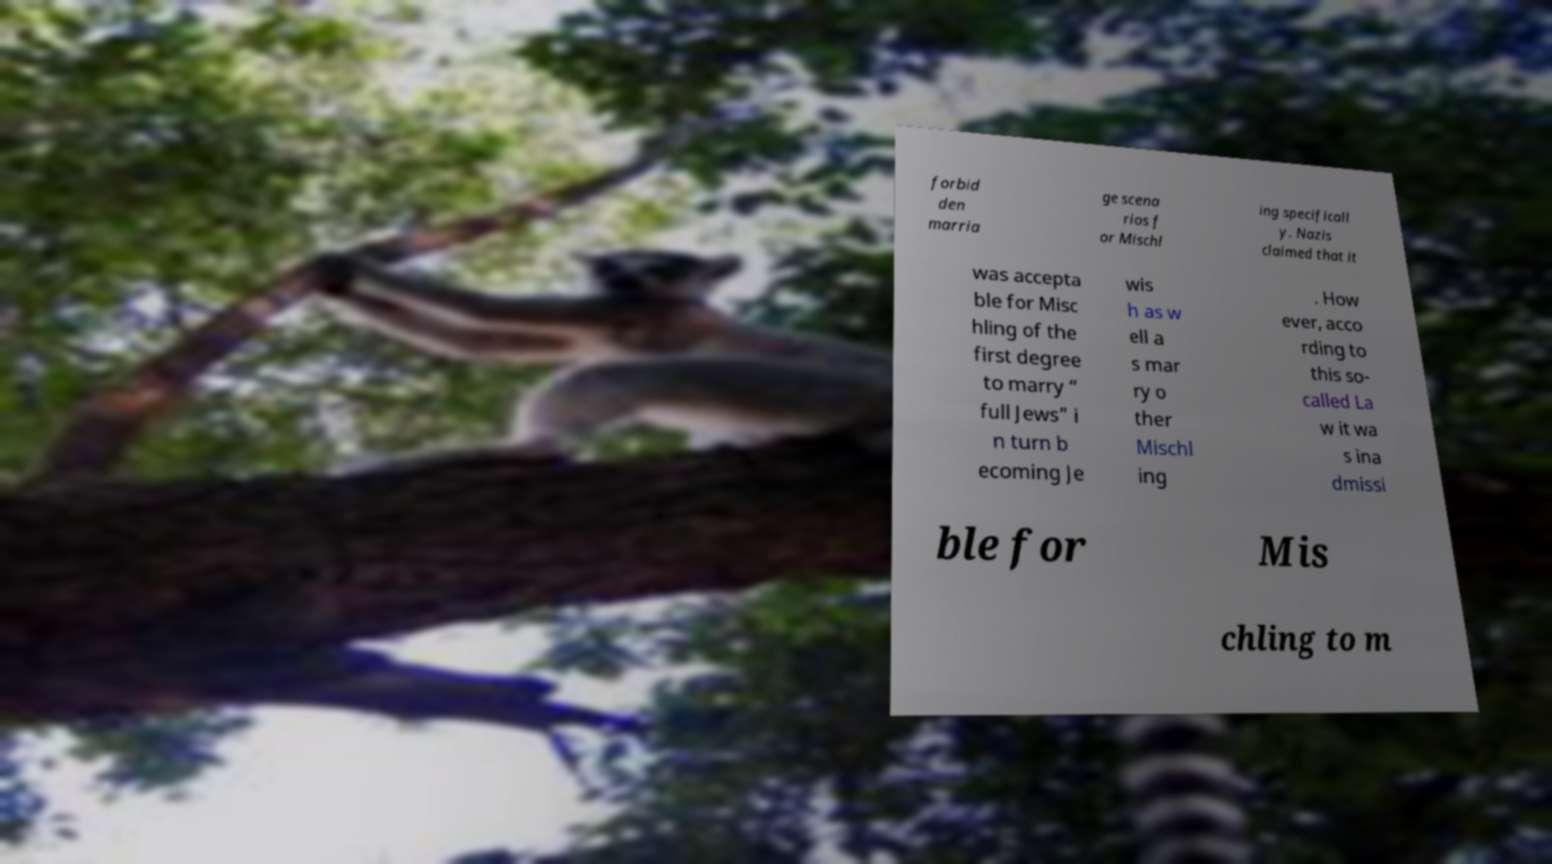There's text embedded in this image that I need extracted. Can you transcribe it verbatim? forbid den marria ge scena rios f or Mischl ing specificall y. Nazis claimed that it was accepta ble for Misc hling of the first degree to marry “ full Jews” i n turn b ecoming Je wis h as w ell a s mar ry o ther Mischl ing . How ever, acco rding to this so- called La w it wa s ina dmissi ble for Mis chling to m 